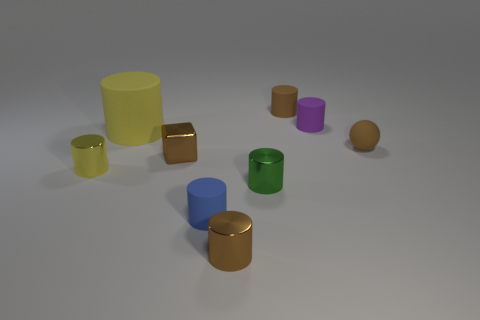Is the number of small things that are behind the yellow shiny object greater than the number of purple metal cylinders?
Make the answer very short. Yes. Do the tiny metal cylinder in front of the green metallic cylinder and the small rubber cylinder in front of the small purple cylinder have the same color?
Offer a very short reply. No. Does the yellow matte thing have the same shape as the purple matte object?
Ensure brevity in your answer.  Yes. Are there any other things that have the same shape as the tiny purple matte object?
Offer a very short reply. Yes. Are the brown thing that is behind the matte ball and the tiny purple cylinder made of the same material?
Keep it short and to the point. Yes. What is the shape of the small object that is both behind the brown block and on the left side of the tiny purple rubber thing?
Provide a succinct answer. Cylinder. There is a small brown metallic thing that is in front of the small blue cylinder; is there a tiny metal object in front of it?
Offer a terse response. No. What number of other objects are the same material as the blue cylinder?
Your answer should be very brief. 4. Does the tiny brown shiny thing on the right side of the metal cube have the same shape as the tiny brown thing to the left of the small blue matte thing?
Your response must be concise. No. Does the small yellow thing have the same material as the large yellow object?
Provide a short and direct response. No. 